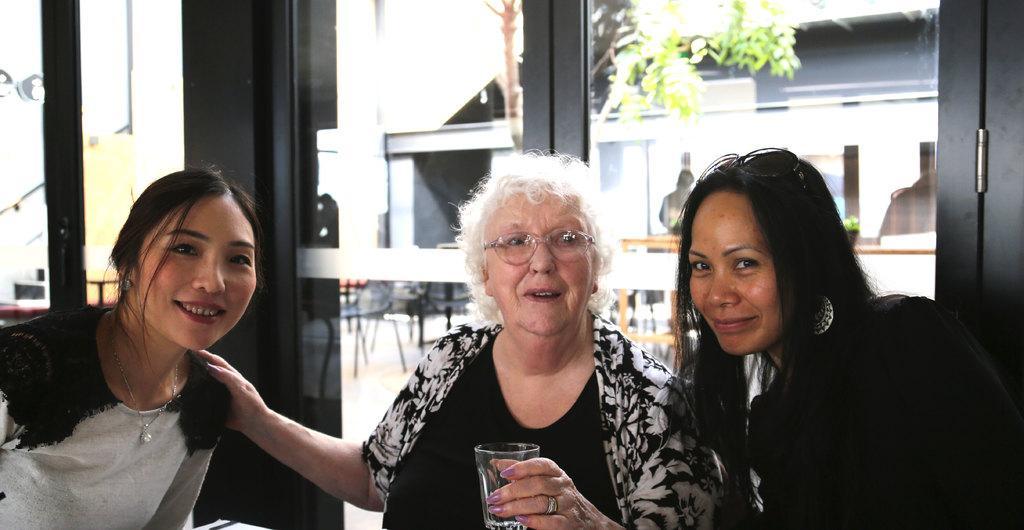Can you describe this image briefly? In this picture we can see three women sitting, among them one woman is holding a glass. Behind the women, there is a glass door. Through the glass door, we can see chairs and a tree. 